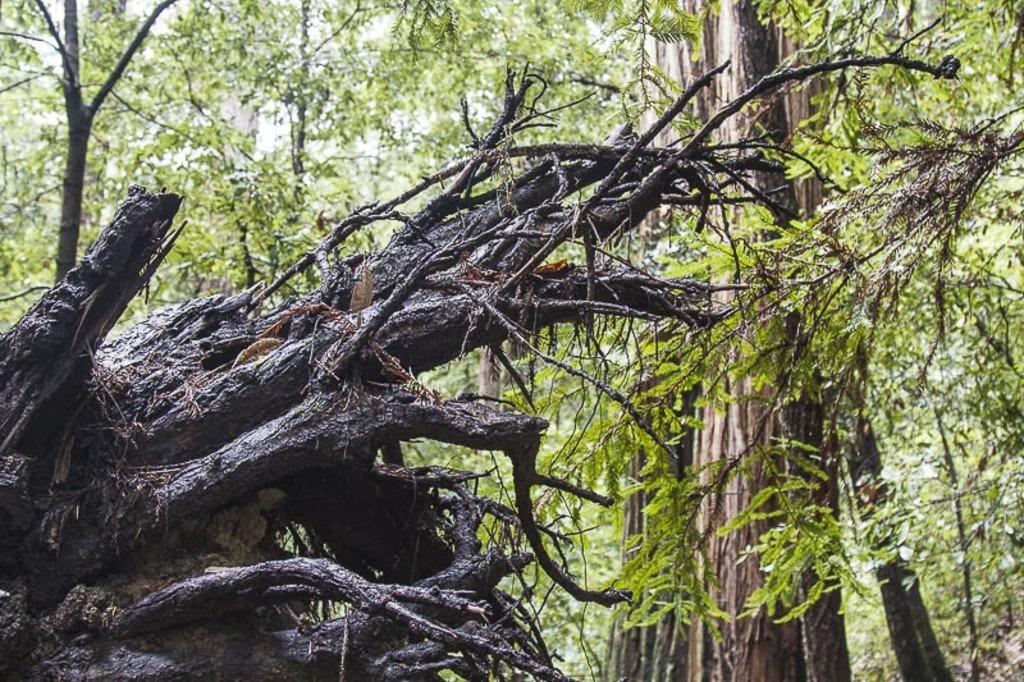What type of tree is present in the image? There is a tree with dried branches in the image. Are there any other trees visible in the image? Yes, there are other trees visible in the image. What type of wind can be seen blowing through the tree in the image? There is no wind visible in the image; it is a still image. What type of dish is the duck being cooked in the image? There is no duck or cooking activity present in the image. 